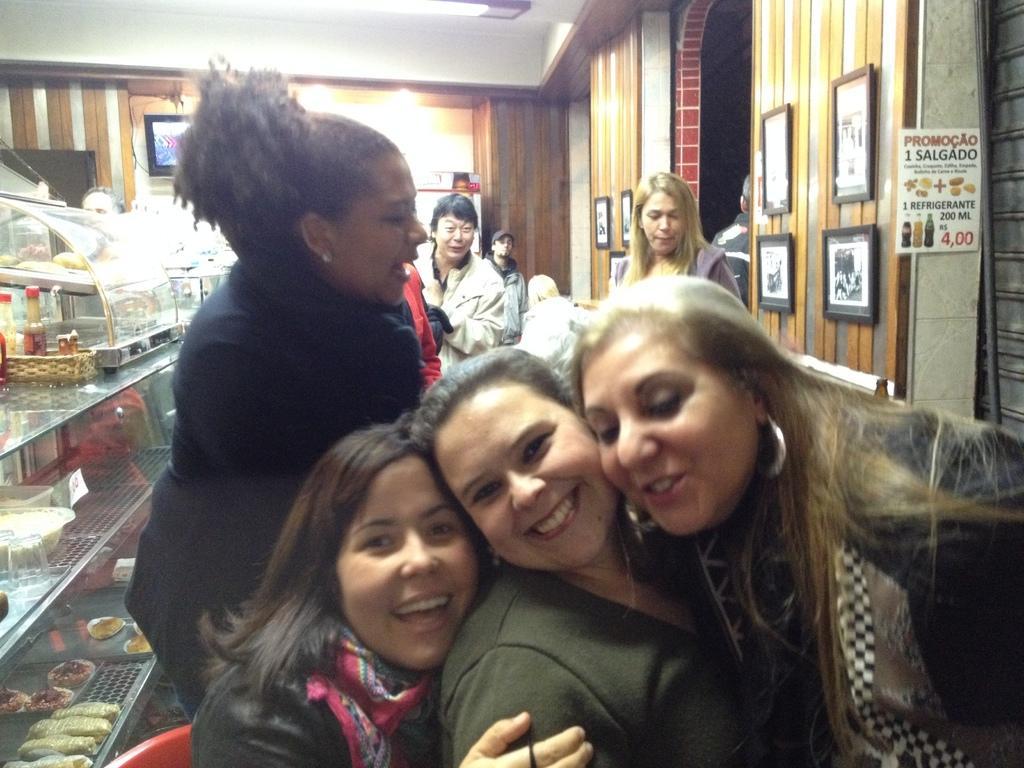How would you summarize this image in a sentence or two? In this image we can see many people. On the right side there is a wall with photo frames. There is a poster with something written. On the left side there is a glass object with racks. Inside that there are food items. Also there are some other items on that. In the back there is a wall with a screen. Also there are lights. 